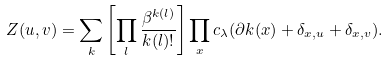Convert formula to latex. <formula><loc_0><loc_0><loc_500><loc_500>Z ( u , v ) = \sum _ { k } \left [ \prod _ { l } \frac { \beta ^ { k ( l ) } } { k ( l ) ! } \right ] \prod _ { x } c _ { \lambda } ( \partial k ( x ) + \delta _ { x , u } + \delta _ { x , v } ) .</formula> 